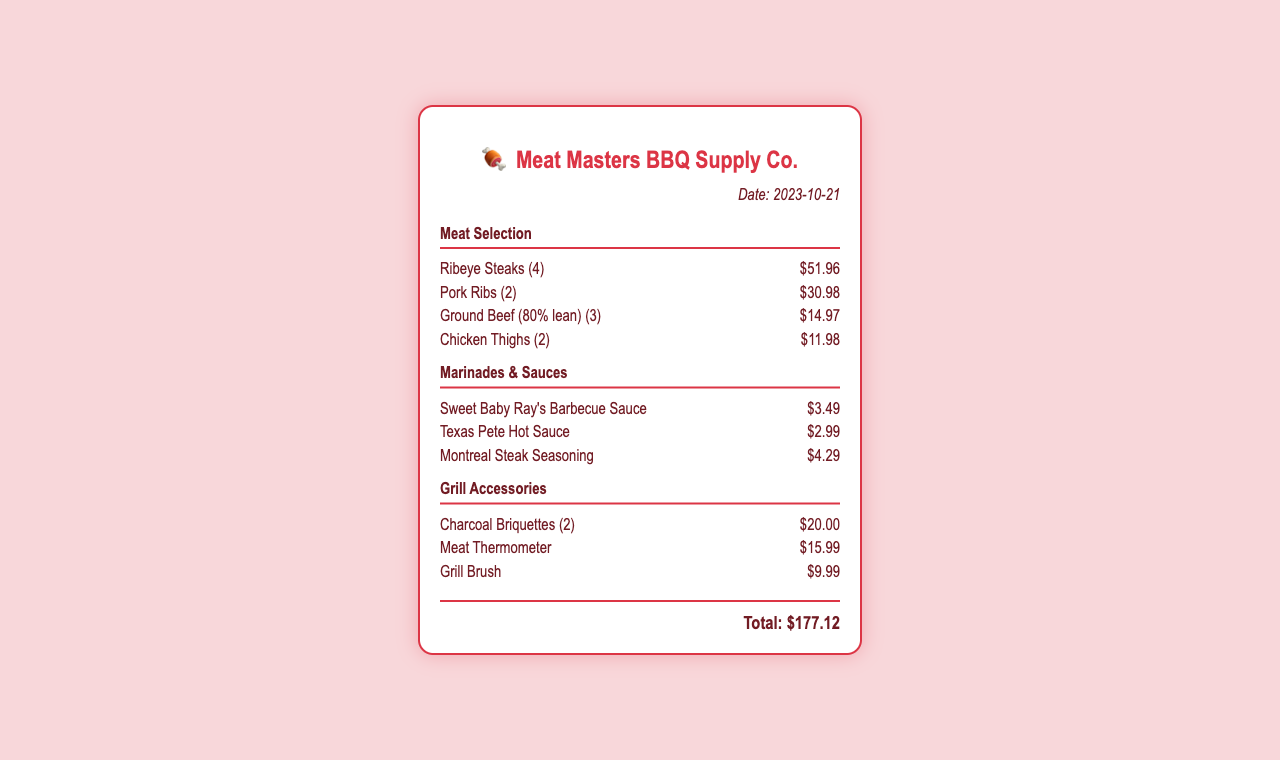what is the date of purchase? The date of purchase is explicitly stated in the document as the purchase date.
Answer: 2023-10-21 how many Ribeye Steaks were purchased? The number of Ribeye Steaks is listed in the meat selection section of the document.
Answer: 4 what is the price of Pork Ribs? The price of Pork Ribs is provided in the meat selection section.
Answer: $30.98 which marinade was purchased? The document lists the marinades and sauces section, which includes the items purchased.
Answer: Sweet Baby Ray's Barbecue Sauce how much did the Meat Thermometer cost? The cost of the Meat Thermometer is specified in the grill accessories section of the document.
Answer: $15.99 what is the total amount spent? The total amount spent is clearly stated at the end of the receipt.
Answer: $177.12 how many items are listed in Grill Accessories? The document provides a list of items under the grill accessories category.
Answer: 3 which seasoning was included in the purchase? The marinade section of the document specifies the seasoning item included in the purchase.
Answer: Montreal Steak Seasoning how many Chicken Thighs were purchased? The number of Chicken Thighs is indicated in the meat selection section of the document.
Answer: 2 